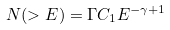<formula> <loc_0><loc_0><loc_500><loc_500>N ( > E ) = \Gamma C _ { 1 } E ^ { - \gamma + 1 }</formula> 